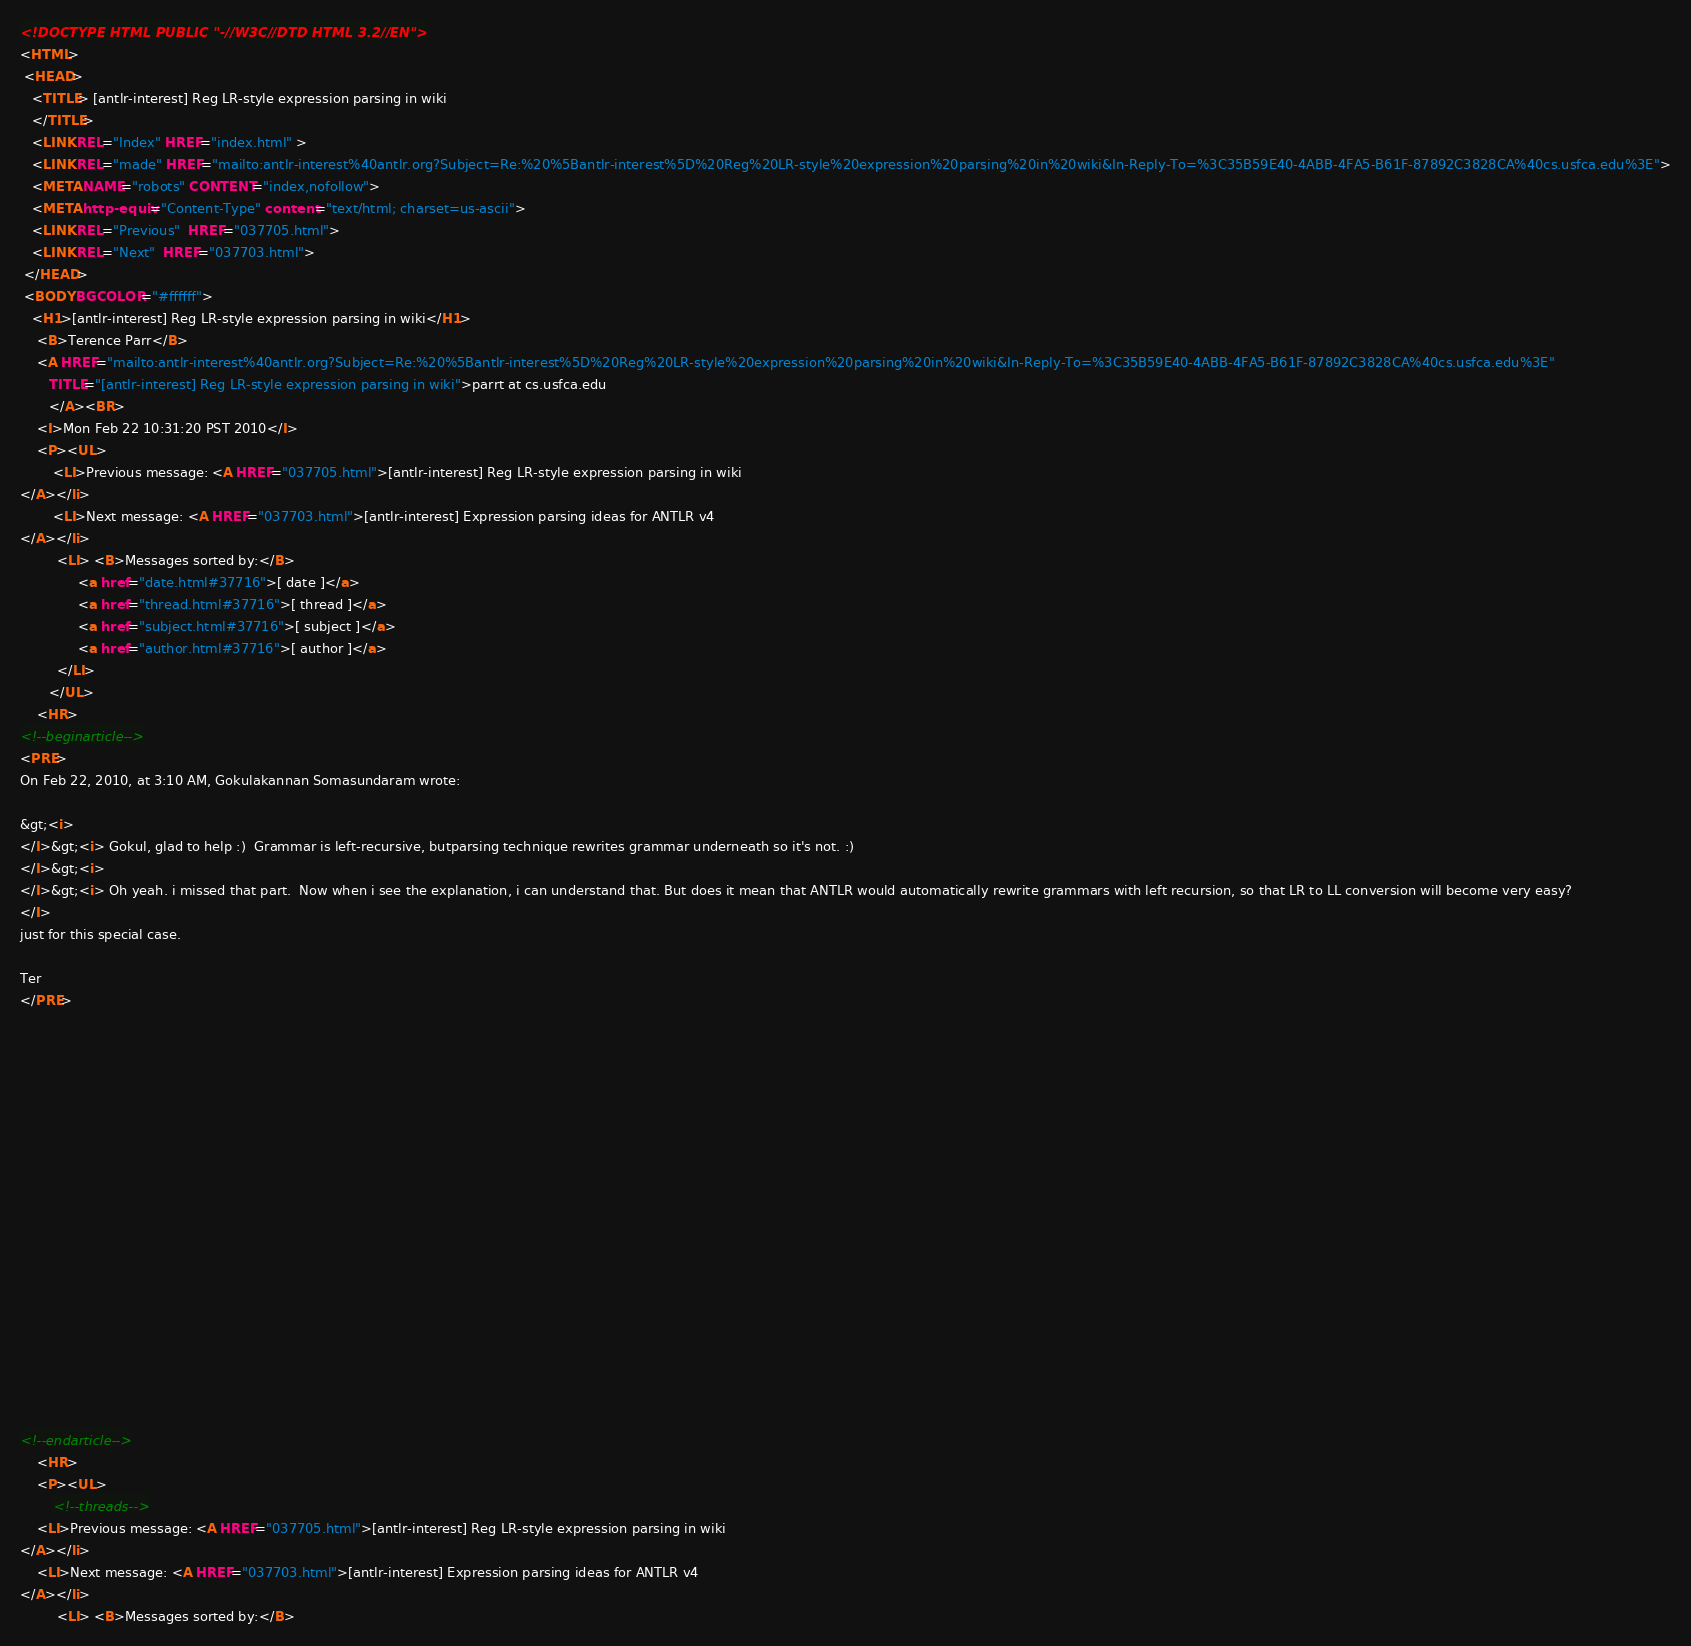Convert code to text. <code><loc_0><loc_0><loc_500><loc_500><_HTML_><!DOCTYPE HTML PUBLIC "-//W3C//DTD HTML 3.2//EN">
<HTML>
 <HEAD>
   <TITLE> [antlr-interest] Reg LR-style expression parsing in wiki
   </TITLE>
   <LINK REL="Index" HREF="index.html" >
   <LINK REL="made" HREF="mailto:antlr-interest%40antlr.org?Subject=Re:%20%5Bantlr-interest%5D%20Reg%20LR-style%20expression%20parsing%20in%20wiki&In-Reply-To=%3C35B59E40-4ABB-4FA5-B61F-87892C3828CA%40cs.usfca.edu%3E">
   <META NAME="robots" CONTENT="index,nofollow">
   <META http-equiv="Content-Type" content="text/html; charset=us-ascii">
   <LINK REL="Previous"  HREF="037705.html">
   <LINK REL="Next"  HREF="037703.html">
 </HEAD>
 <BODY BGCOLOR="#ffffff">
   <H1>[antlr-interest] Reg LR-style expression parsing in wiki</H1>
    <B>Terence Parr</B> 
    <A HREF="mailto:antlr-interest%40antlr.org?Subject=Re:%20%5Bantlr-interest%5D%20Reg%20LR-style%20expression%20parsing%20in%20wiki&In-Reply-To=%3C35B59E40-4ABB-4FA5-B61F-87892C3828CA%40cs.usfca.edu%3E"
       TITLE="[antlr-interest] Reg LR-style expression parsing in wiki">parrt at cs.usfca.edu
       </A><BR>
    <I>Mon Feb 22 10:31:20 PST 2010</I>
    <P><UL>
        <LI>Previous message: <A HREF="037705.html">[antlr-interest] Reg LR-style expression parsing in wiki
</A></li>
        <LI>Next message: <A HREF="037703.html">[antlr-interest] Expression parsing ideas for ANTLR v4
</A></li>
         <LI> <B>Messages sorted by:</B> 
              <a href="date.html#37716">[ date ]</a>
              <a href="thread.html#37716">[ thread ]</a>
              <a href="subject.html#37716">[ subject ]</a>
              <a href="author.html#37716">[ author ]</a>
         </LI>
       </UL>
    <HR>  
<!--beginarticle-->
<PRE>
On Feb 22, 2010, at 3:10 AM, Gokulakannan Somasundaram wrote:

&gt;<i> 
</I>&gt;<i> Gokul, glad to help :)  Grammar is left-recursive, butparsing technique rewrites grammar underneath so it's not. :)
</I>&gt;<i> 
</I>&gt;<i> Oh yeah. i missed that part.  Now when i see the explanation, i can understand that. But does it mean that ANTLR would automatically rewrite grammars with left recursion, so that LR to LL conversion will become very easy?
</I>
just for this special case.

Ter
</PRE>



















<!--endarticle-->
    <HR>
    <P><UL>
        <!--threads-->
	<LI>Previous message: <A HREF="037705.html">[antlr-interest] Reg LR-style expression parsing in wiki
</A></li>
	<LI>Next message: <A HREF="037703.html">[antlr-interest] Expression parsing ideas for ANTLR v4
</A></li>
         <LI> <B>Messages sorted by:</B> </code> 